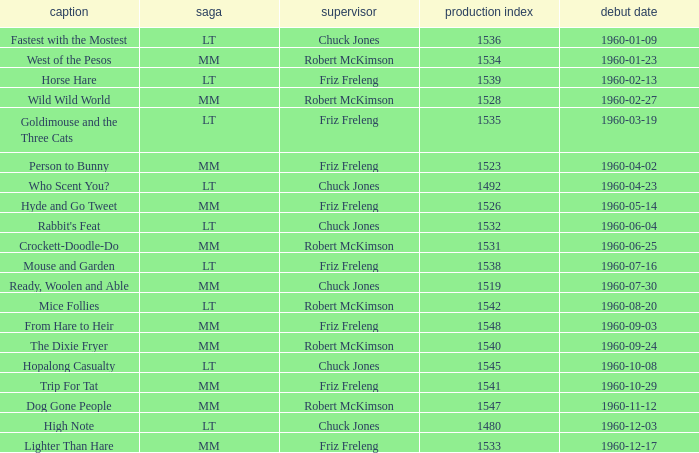What is the production number of From Hare to Heir? 1548.0. 